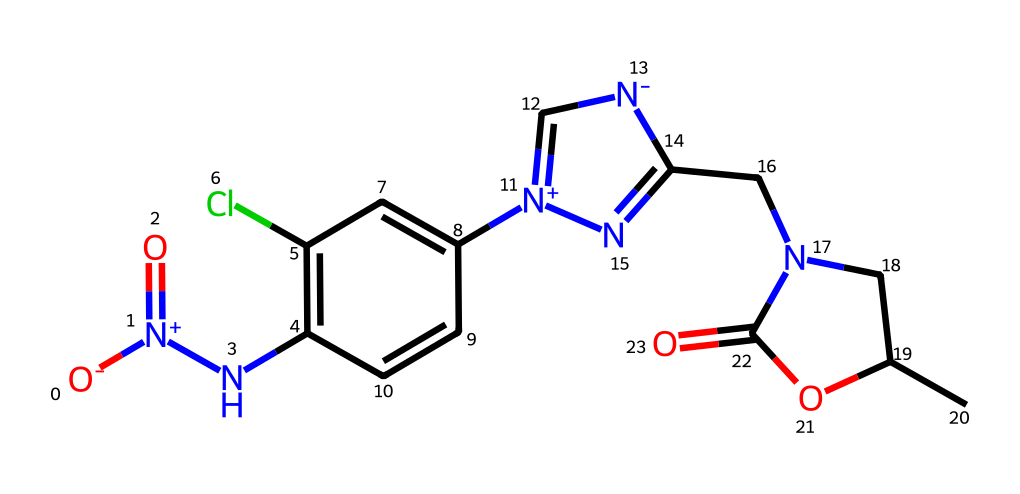What is the molecular formula of imidacloprid? By examining the SMILES representation, we can count the number of each type of atom present. The structure consists of carbon (C), hydrogen (H), nitrogen (N), oxygen (O), and chlorine (Cl). Counting these gives us C9H10ClN5O2.
Answer: C9H10ClN5O2 How many rings are present in the molecular structure? Looking closely at the structure, we can identify distinct cyclic arrangements of atoms. There are two rings present; one is a pyridine ring and another is a bicyclic system involving nitrogen.
Answer: 2 What type of bond is primarily present in imidacloprid? The majority of the bonds within the structure are covalent bonds, which are formed by the sharing of electron pairs between atoms. The SMILES representation indicates multiple such bonds, especially within the rings and connecting nitrogen atoms.
Answer: covalent What is the primary functional group in imidacloprid? Upon inspecting the structure, we can identify significant functional groups. The presence of a nitro (NO2) and a guanidine (C(N)N) group indicates that the primary functional group of interest, linked to its insecticidal properties, is indeed nitro.
Answer: nitro What molecular feature contributes to the insecticidal activity of imidacloprid? Analyzing the SMILES structure reveals the presence of a nitro group and a chlorine atom, which are crucial for its biological activity. The lipophilic character of the chlorinated compound enhances the penetration into insect nervous systems, contributing to its toxicity.
Answer: nitro group Does imidacloprid contain any halogen atoms? By filtering through the atoms in the structure as denoted by the SMILES, we can identify halogen presence. Specifically, a chlorine atom is present, confirming the presence of a halogen in this compound.
Answer: yes 